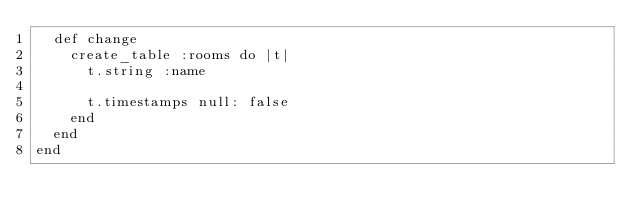Convert code to text. <code><loc_0><loc_0><loc_500><loc_500><_Ruby_>  def change
    create_table :rooms do |t|
      t.string :name

      t.timestamps null: false
    end
  end
end
</code> 